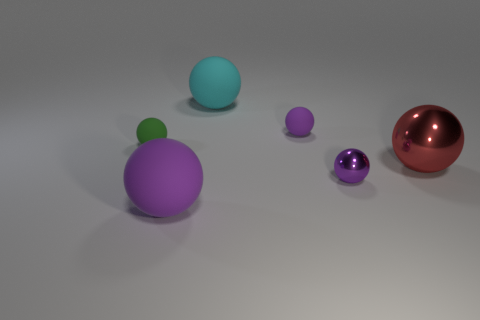Are there more big red rubber cylinders than cyan balls?
Your answer should be compact. No. There is a tiny object in front of the large red shiny thing; is it the same color as the big metal ball?
Give a very brief answer. No. The big shiny object has what color?
Offer a very short reply. Red. There is a tiny rubber object that is on the left side of the large cyan ball; is there a metallic ball that is in front of it?
Provide a short and direct response. Yes. The small rubber object on the left side of the large matte thing behind the green ball is what shape?
Provide a short and direct response. Sphere. Are there fewer red spheres than large rubber things?
Make the answer very short. Yes. Is the material of the small green object the same as the big red sphere?
Keep it short and to the point. No. The matte ball that is on the left side of the cyan rubber thing and behind the big shiny ball is what color?
Keep it short and to the point. Green. Are there any purple matte balls of the same size as the red shiny ball?
Offer a very short reply. Yes. There is a red metallic sphere that is right of the tiny sphere that is in front of the red sphere; what is its size?
Your answer should be very brief. Large. 